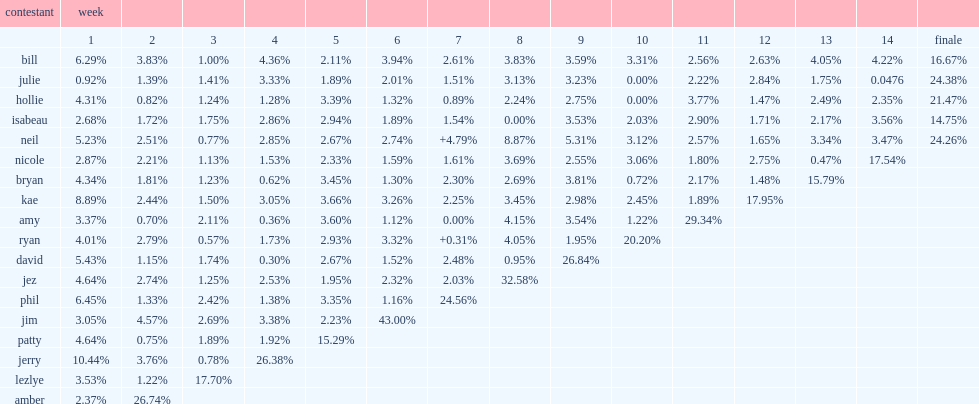How many percent of weight loss of julie was week 14's biggest loser? 0.0476. 